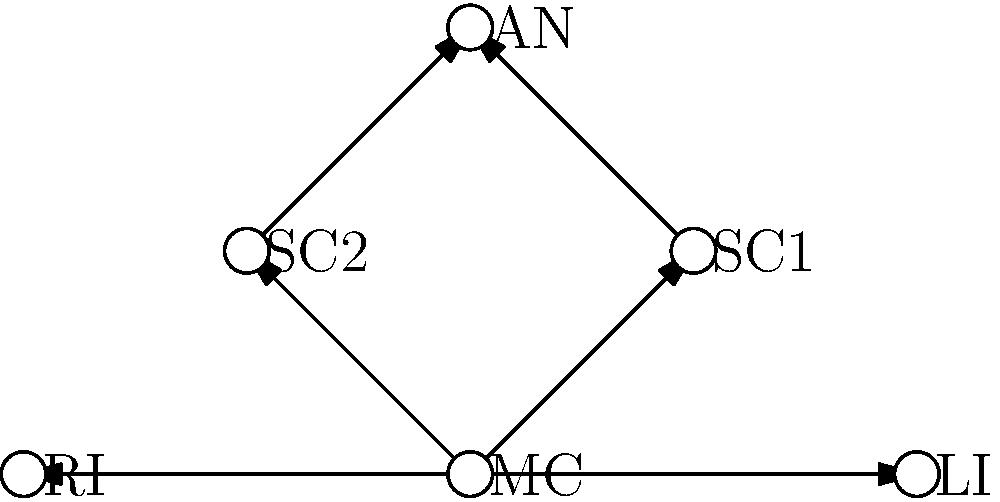In the network diagram representing character relationships in a manga, which character has the highest degree centrality (most direct connections)? How does this information help in developing the manga's storyline? To answer this question, we need to follow these steps:

1. Understand the concept of degree centrality:
   Degree centrality is the number of direct connections a node has in a network.

2. Identify the characters in the network:
   MC: Main Character
   SC1: Supporting Character 1
   SC2: Supporting Character 2
   AN: Antagonist
   RI: Rival
   LI: Love Interest

3. Count the connections for each character:
   MC: 5 connections (SC1, SC2, AN, RI, LI)
   SC1: 2 connections (MC, AN)
   SC2: 2 connections (MC, AN)
   AN: 2 connections (SC1, SC2)
   RI: 1 connection (MC)
   LI: 1 connection (MC)

4. Determine the character with the highest degree centrality:
   The Main Character (MC) has the highest degree centrality with 5 connections.

5. Analyze how this information helps in developing the manga's storyline:
   - The MC's high centrality indicates they are the focal point of the story.
   - It suggests multiple plot threads and relationships to explore.
   - The MC's connections to diverse characters (supporting characters, antagonist, rival, and love interest) provide opportunities for varied story arcs and character development.
   - The network structure implies potential for complex interactions and conflicts centered around the MC.

This information can guide the writer in creating a rich, interconnected narrative that leverages the MC's central position in the character network.
Answer: MC (Main Character); guides plot complexity and character interactions 